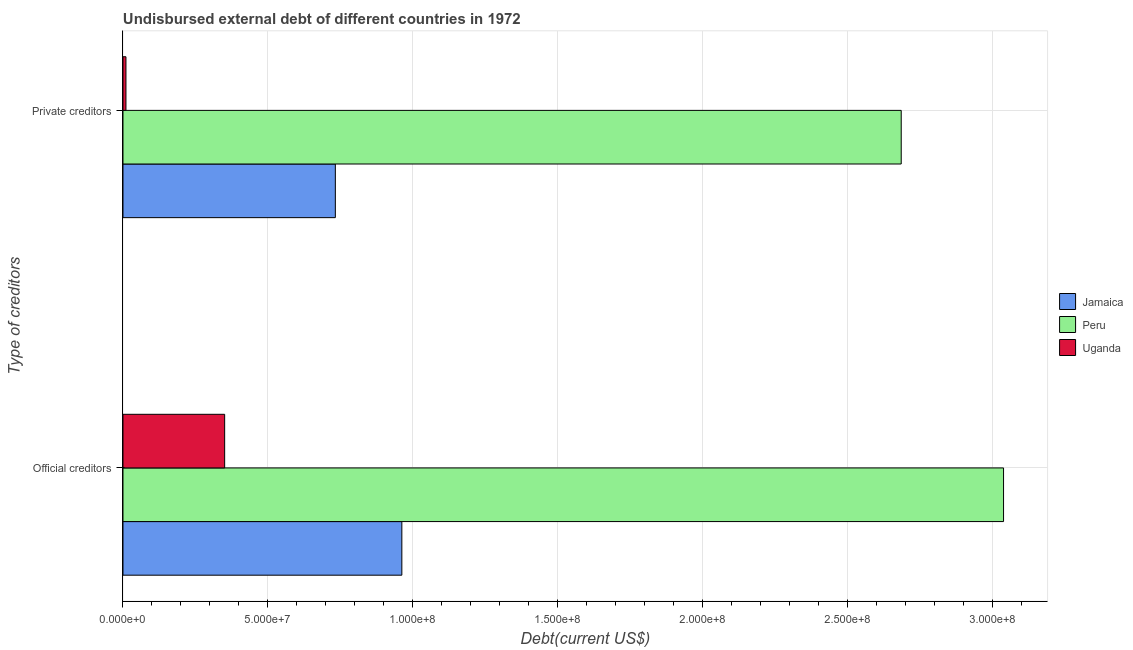How many groups of bars are there?
Your answer should be very brief. 2. What is the label of the 2nd group of bars from the top?
Your answer should be compact. Official creditors. What is the undisbursed external debt of official creditors in Jamaica?
Offer a terse response. 9.62e+07. Across all countries, what is the maximum undisbursed external debt of official creditors?
Keep it short and to the point. 3.04e+08. Across all countries, what is the minimum undisbursed external debt of private creditors?
Keep it short and to the point. 1.03e+06. In which country was the undisbursed external debt of private creditors minimum?
Make the answer very short. Uganda. What is the total undisbursed external debt of private creditors in the graph?
Your answer should be very brief. 3.43e+08. What is the difference between the undisbursed external debt of official creditors in Peru and that in Jamaica?
Keep it short and to the point. 2.08e+08. What is the difference between the undisbursed external debt of official creditors in Uganda and the undisbursed external debt of private creditors in Peru?
Your answer should be compact. -2.33e+08. What is the average undisbursed external debt of private creditors per country?
Keep it short and to the point. 1.14e+08. What is the difference between the undisbursed external debt of official creditors and undisbursed external debt of private creditors in Peru?
Make the answer very short. 3.53e+07. In how many countries, is the undisbursed external debt of official creditors greater than 250000000 US$?
Ensure brevity in your answer.  1. What is the ratio of the undisbursed external debt of private creditors in Jamaica to that in Peru?
Offer a terse response. 0.27. What does the 1st bar from the top in Private creditors represents?
Your answer should be very brief. Uganda. What does the 1st bar from the bottom in Private creditors represents?
Make the answer very short. Jamaica. How many countries are there in the graph?
Provide a short and direct response. 3. What is the difference between two consecutive major ticks on the X-axis?
Keep it short and to the point. 5.00e+07. Are the values on the major ticks of X-axis written in scientific E-notation?
Ensure brevity in your answer.  Yes. Does the graph contain any zero values?
Provide a succinct answer. No. How are the legend labels stacked?
Provide a succinct answer. Vertical. What is the title of the graph?
Make the answer very short. Undisbursed external debt of different countries in 1972. Does "Tonga" appear as one of the legend labels in the graph?
Make the answer very short. No. What is the label or title of the X-axis?
Keep it short and to the point. Debt(current US$). What is the label or title of the Y-axis?
Provide a short and direct response. Type of creditors. What is the Debt(current US$) of Jamaica in Official creditors?
Provide a short and direct response. 9.62e+07. What is the Debt(current US$) of Peru in Official creditors?
Your answer should be very brief. 3.04e+08. What is the Debt(current US$) in Uganda in Official creditors?
Make the answer very short. 3.51e+07. What is the Debt(current US$) of Jamaica in Private creditors?
Your answer should be compact. 7.32e+07. What is the Debt(current US$) of Peru in Private creditors?
Ensure brevity in your answer.  2.68e+08. What is the Debt(current US$) in Uganda in Private creditors?
Your response must be concise. 1.03e+06. Across all Type of creditors, what is the maximum Debt(current US$) of Jamaica?
Provide a short and direct response. 9.62e+07. Across all Type of creditors, what is the maximum Debt(current US$) of Peru?
Your response must be concise. 3.04e+08. Across all Type of creditors, what is the maximum Debt(current US$) in Uganda?
Give a very brief answer. 3.51e+07. Across all Type of creditors, what is the minimum Debt(current US$) of Jamaica?
Give a very brief answer. 7.32e+07. Across all Type of creditors, what is the minimum Debt(current US$) of Peru?
Your response must be concise. 2.68e+08. Across all Type of creditors, what is the minimum Debt(current US$) in Uganda?
Make the answer very short. 1.03e+06. What is the total Debt(current US$) in Jamaica in the graph?
Your answer should be compact. 1.69e+08. What is the total Debt(current US$) in Peru in the graph?
Your answer should be compact. 5.72e+08. What is the total Debt(current US$) in Uganda in the graph?
Give a very brief answer. 3.61e+07. What is the difference between the Debt(current US$) in Jamaica in Official creditors and that in Private creditors?
Your answer should be compact. 2.29e+07. What is the difference between the Debt(current US$) in Peru in Official creditors and that in Private creditors?
Your answer should be compact. 3.53e+07. What is the difference between the Debt(current US$) of Uganda in Official creditors and that in Private creditors?
Provide a short and direct response. 3.40e+07. What is the difference between the Debt(current US$) of Jamaica in Official creditors and the Debt(current US$) of Peru in Private creditors?
Your response must be concise. -1.72e+08. What is the difference between the Debt(current US$) in Jamaica in Official creditors and the Debt(current US$) in Uganda in Private creditors?
Provide a short and direct response. 9.52e+07. What is the difference between the Debt(current US$) in Peru in Official creditors and the Debt(current US$) in Uganda in Private creditors?
Offer a very short reply. 3.03e+08. What is the average Debt(current US$) of Jamaica per Type of creditors?
Your response must be concise. 8.47e+07. What is the average Debt(current US$) in Peru per Type of creditors?
Offer a very short reply. 2.86e+08. What is the average Debt(current US$) of Uganda per Type of creditors?
Your answer should be compact. 1.80e+07. What is the difference between the Debt(current US$) in Jamaica and Debt(current US$) in Peru in Official creditors?
Your response must be concise. -2.08e+08. What is the difference between the Debt(current US$) in Jamaica and Debt(current US$) in Uganda in Official creditors?
Provide a short and direct response. 6.11e+07. What is the difference between the Debt(current US$) in Peru and Debt(current US$) in Uganda in Official creditors?
Make the answer very short. 2.69e+08. What is the difference between the Debt(current US$) in Jamaica and Debt(current US$) in Peru in Private creditors?
Your answer should be very brief. -1.95e+08. What is the difference between the Debt(current US$) of Jamaica and Debt(current US$) of Uganda in Private creditors?
Your response must be concise. 7.22e+07. What is the difference between the Debt(current US$) in Peru and Debt(current US$) in Uganda in Private creditors?
Keep it short and to the point. 2.67e+08. What is the ratio of the Debt(current US$) in Jamaica in Official creditors to that in Private creditors?
Make the answer very short. 1.31. What is the ratio of the Debt(current US$) of Peru in Official creditors to that in Private creditors?
Your answer should be compact. 1.13. What is the ratio of the Debt(current US$) in Uganda in Official creditors to that in Private creditors?
Ensure brevity in your answer.  34.19. What is the difference between the highest and the second highest Debt(current US$) in Jamaica?
Give a very brief answer. 2.29e+07. What is the difference between the highest and the second highest Debt(current US$) of Peru?
Provide a succinct answer. 3.53e+07. What is the difference between the highest and the second highest Debt(current US$) in Uganda?
Offer a very short reply. 3.40e+07. What is the difference between the highest and the lowest Debt(current US$) of Jamaica?
Keep it short and to the point. 2.29e+07. What is the difference between the highest and the lowest Debt(current US$) of Peru?
Provide a succinct answer. 3.53e+07. What is the difference between the highest and the lowest Debt(current US$) in Uganda?
Your response must be concise. 3.40e+07. 